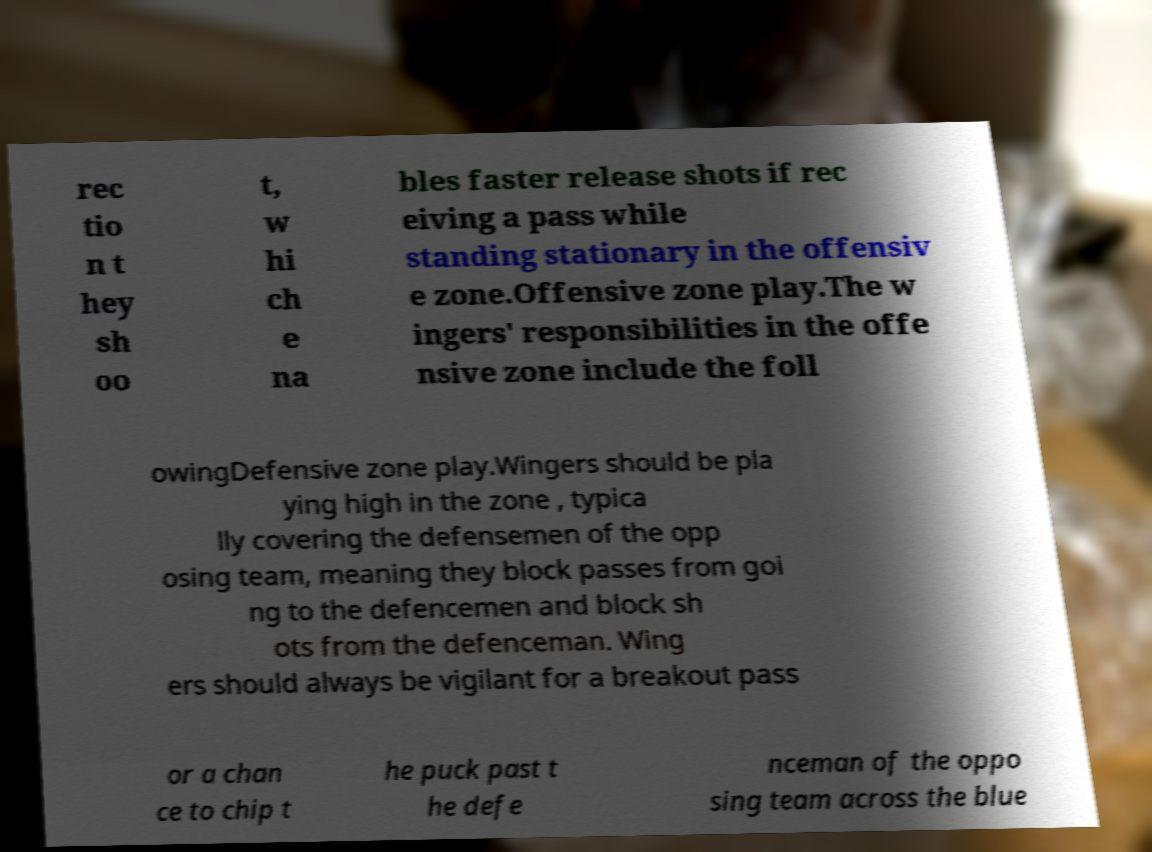Please identify and transcribe the text found in this image. rec tio n t hey sh oo t, w hi ch e na bles faster release shots if rec eiving a pass while standing stationary in the offensiv e zone.Offensive zone play.The w ingers' responsibilities in the offe nsive zone include the foll owingDefensive zone play.Wingers should be pla ying high in the zone , typica lly covering the defensemen of the opp osing team, meaning they block passes from goi ng to the defencemen and block sh ots from the defenceman. Wing ers should always be vigilant for a breakout pass or a chan ce to chip t he puck past t he defe nceman of the oppo sing team across the blue 